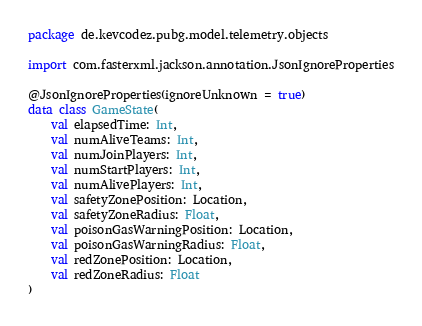<code> <loc_0><loc_0><loc_500><loc_500><_Kotlin_>package de.kevcodez.pubg.model.telemetry.objects

import com.fasterxml.jackson.annotation.JsonIgnoreProperties

@JsonIgnoreProperties(ignoreUnknown = true)
data class GameState(
    val elapsedTime: Int,
    val numAliveTeams: Int,
    val numJoinPlayers: Int,
    val numStartPlayers: Int,
    val numAlivePlayers: Int,
    val safetyZonePosition: Location,
    val safetyZoneRadius: Float,
    val poisonGasWarningPosition: Location,
    val poisonGasWarningRadius: Float,
    val redZonePosition: Location,
    val redZoneRadius: Float
)
</code> 